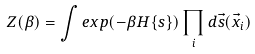Convert formula to latex. <formula><loc_0><loc_0><loc_500><loc_500>Z ( \beta ) = \int e x p ( - \beta H \{ s \} ) \prod _ { i } d \vec { s } ( \vec { x } _ { i } )</formula> 